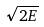<formula> <loc_0><loc_0><loc_500><loc_500>\sqrt { 2 E }</formula> 